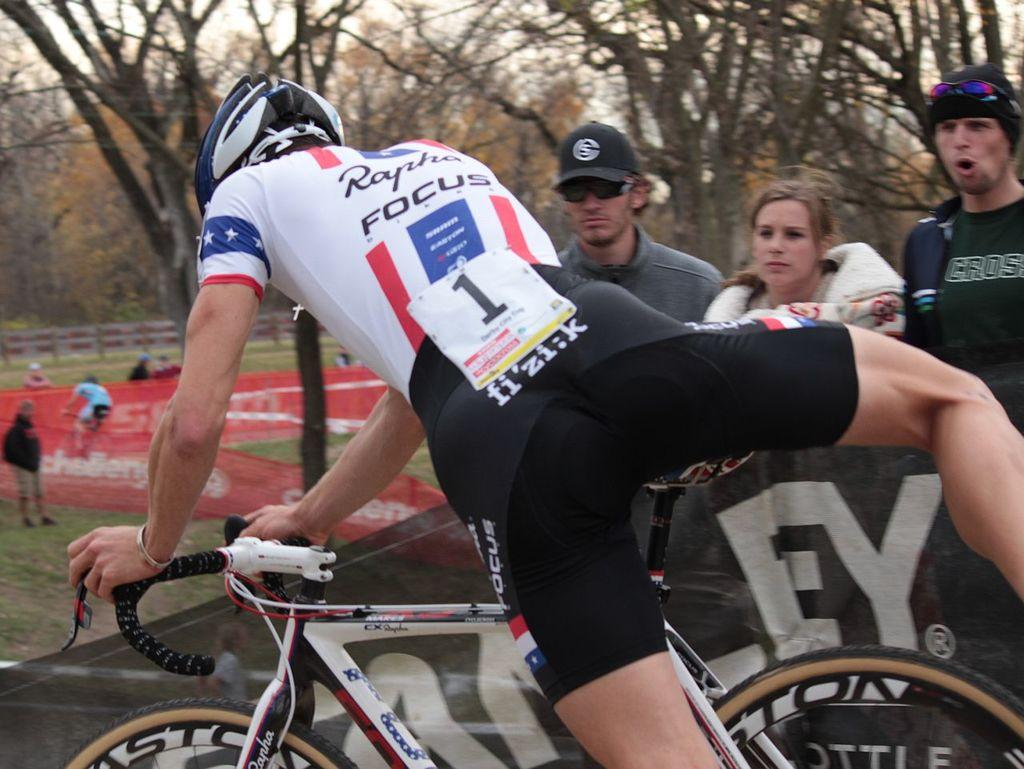What is the main subject of the image? There is a person in the process of sitting on a bicycle. How many other people are in the image? There are three other persons in the image. What can be seen in the background of the image? There are trees, a fence, and the sky visible in the background. Are there any additional people in the background? Yes, there are additional persons in the background. What color is the wren's shirt in the image? There is no wren present in the image, and therefore no shirt to describe. 